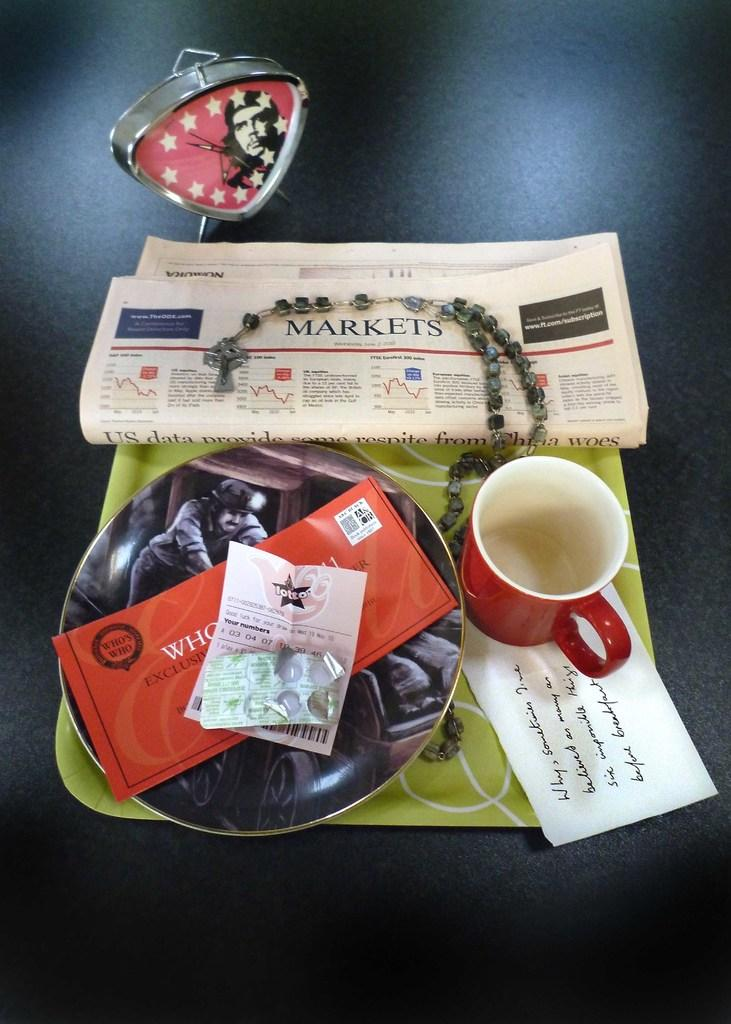<image>
Present a compact description of the photo's key features. a plate with a newspaper reading Markets has a cup and plate also 